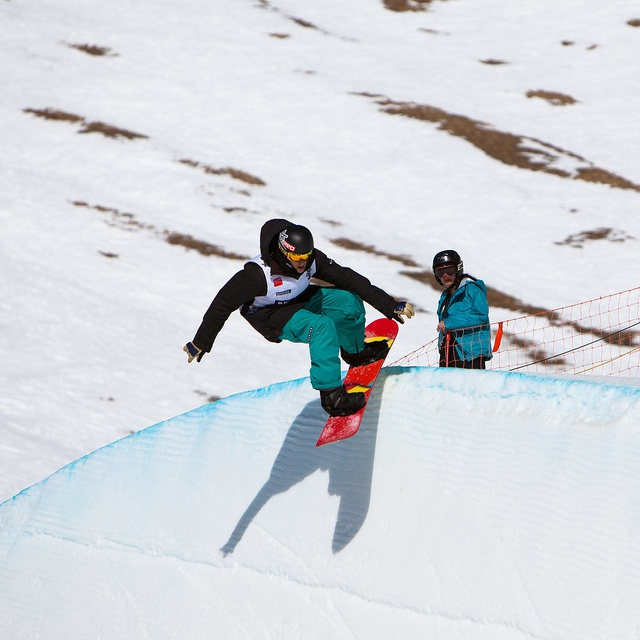Describe the objects in this image and their specific colors. I can see people in lightgray, black, teal, and lavender tones, people in lightgray, black, and teal tones, and snowboard in lightgray, brown, salmon, and black tones in this image. 